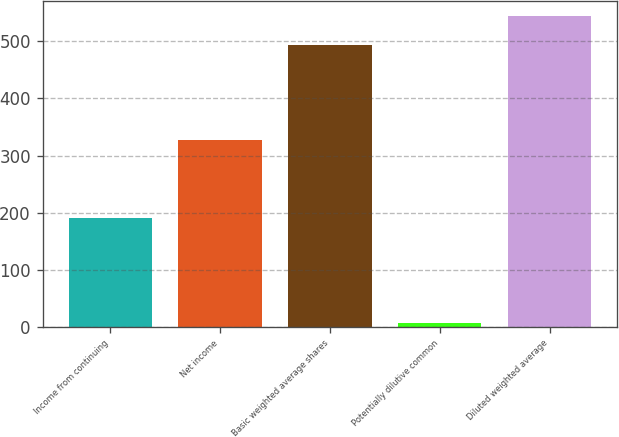Convert chart to OTSL. <chart><loc_0><loc_0><loc_500><loc_500><bar_chart><fcel>Income from continuing<fcel>Net income<fcel>Basic weighted average shares<fcel>Potentially dilutive common<fcel>Diluted weighted average<nl><fcel>191<fcel>327<fcel>494<fcel>6<fcel>543.4<nl></chart> 